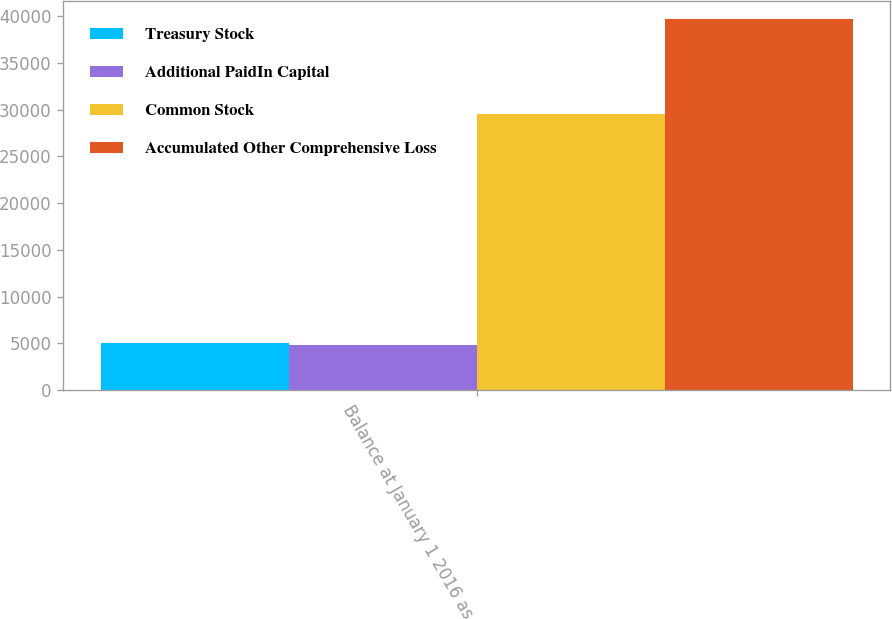<chart> <loc_0><loc_0><loc_500><loc_500><stacked_bar_chart><ecel><fcel>Balance at January 1 2016 as<nl><fcel>Treasury Stock<fcel>5061<nl><fcel>Additional PaidIn Capital<fcel>4834<nl><fcel>Common Stock<fcel>29568<nl><fcel>Accumulated Other Comprehensive Loss<fcel>39657<nl></chart> 